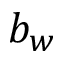Convert formula to latex. <formula><loc_0><loc_0><loc_500><loc_500>b _ { w }</formula> 